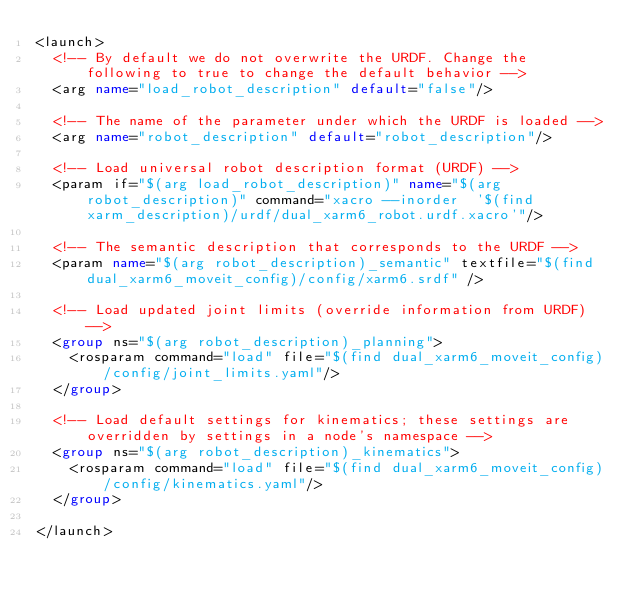Convert code to text. <code><loc_0><loc_0><loc_500><loc_500><_XML_><launch>
  <!-- By default we do not overwrite the URDF. Change the following to true to change the default behavior -->
  <arg name="load_robot_description" default="false"/>

  <!-- The name of the parameter under which the URDF is loaded -->
  <arg name="robot_description" default="robot_description"/>

  <!-- Load universal robot description format (URDF) -->
  <param if="$(arg load_robot_description)" name="$(arg robot_description)" command="xacro --inorder  '$(find xarm_description)/urdf/dual_xarm6_robot.urdf.xacro'"/>

  <!-- The semantic description that corresponds to the URDF -->
  <param name="$(arg robot_description)_semantic" textfile="$(find dual_xarm6_moveit_config)/config/xarm6.srdf" />

  <!-- Load updated joint limits (override information from URDF) -->
  <group ns="$(arg robot_description)_planning">
    <rosparam command="load" file="$(find dual_xarm6_moveit_config)/config/joint_limits.yaml"/>
  </group>

  <!-- Load default settings for kinematics; these settings are overridden by settings in a node's namespace -->
  <group ns="$(arg robot_description)_kinematics">
    <rosparam command="load" file="$(find dual_xarm6_moveit_config)/config/kinematics.yaml"/>
  </group>

</launch>
</code> 